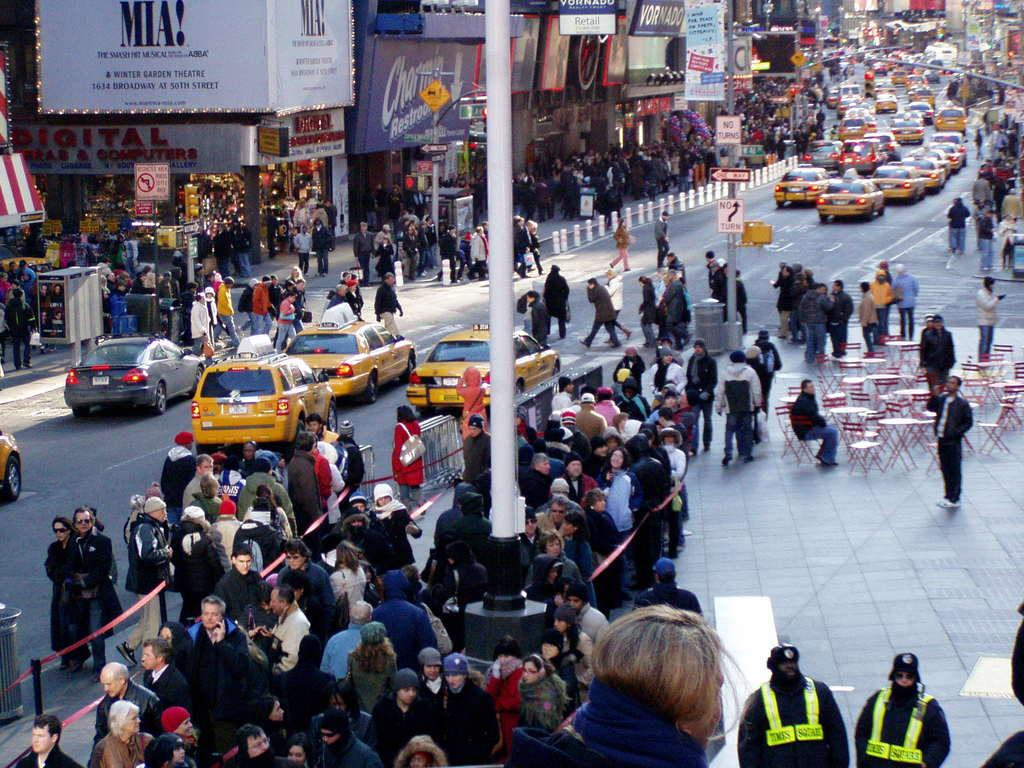<image>
Relay a brief, clear account of the picture shown. A birds eye shot of Times Square. There are lot of people and yellow cabs and a poster for Mama Mia the musical. 